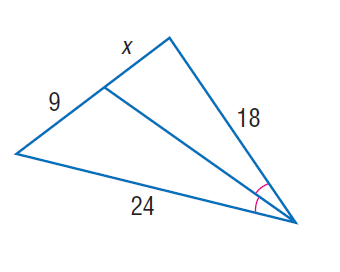Answer the mathemtical geometry problem and directly provide the correct option letter.
Question: Find x.
Choices: A: 6 B: 6.25 C: 6.5 D: 6.75 D 